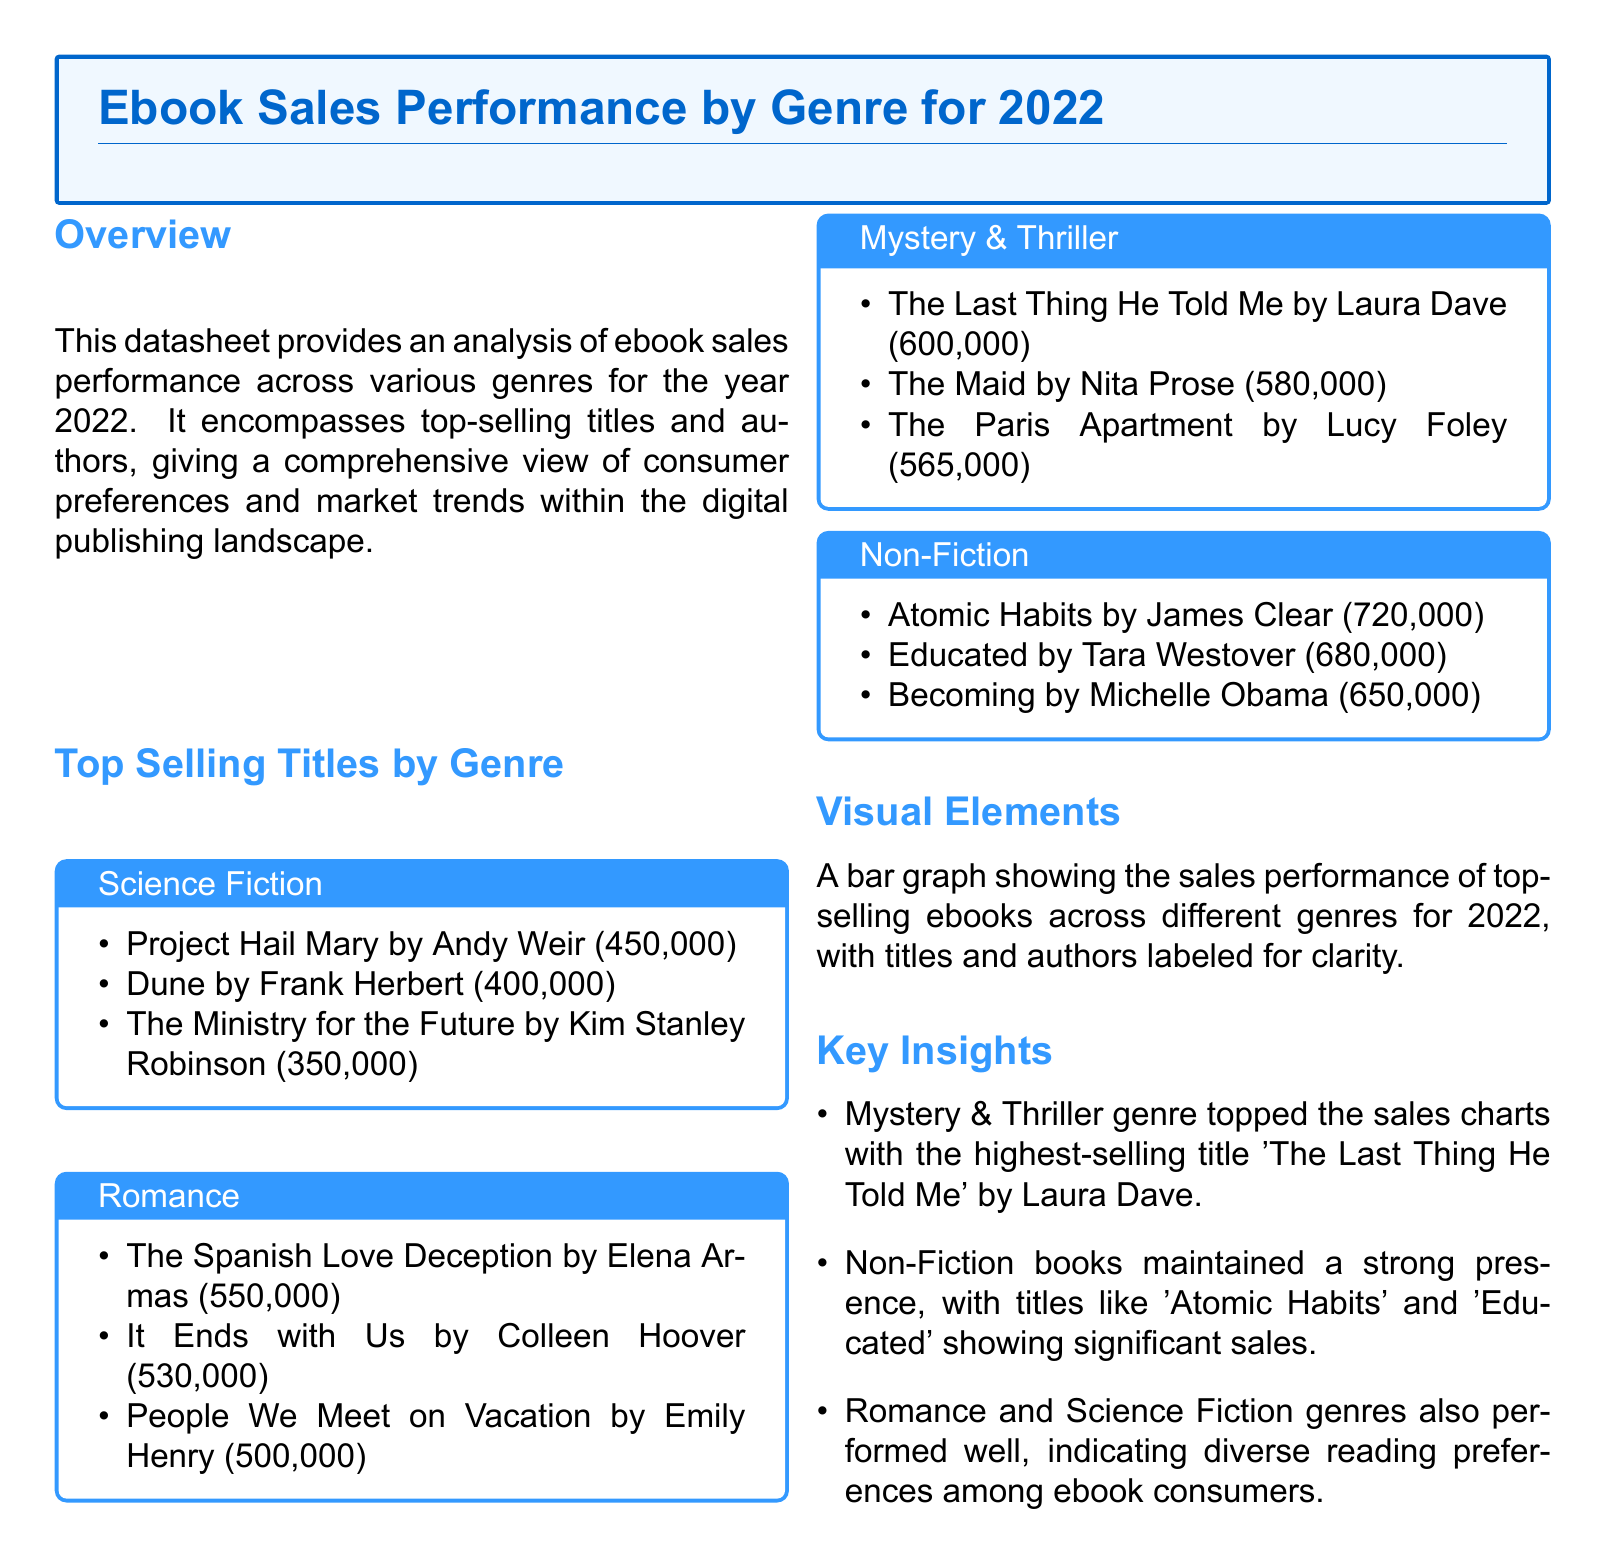what is the highest-selling title in the Mystery & Thriller genre? The highest-selling title is identified in the document under the Mystery & Thriller genre section.
Answer: The Last Thing He Told Me how many copies did Atomic Habits sell? The number of copies sold is specified in the Non-Fiction section of the document.
Answer: 720,000 which author wrote The Spanish Love Deception? The author of The Spanish Love Deception is listed in the Romance section.
Answer: Elena Armas what genre had the top-selling title in 2022? The genre corresponding to the highest-selling title is indicated under the Key Insights section.
Answer: Mystery & Thriller how many copies did The Ministry for the Future sell? The sales figures for The Ministry for the Future are provided in the Science Fiction section.
Answer: 350,000 which title sold 680,000 copies? The sales figure for this title is found in the Non-Fiction section.
Answer: Educated who is the author of the best-selling Romance title? The best-selling title in Romance is detailed, along with its author in the document.
Answer: Colleen Hoover what were the total sales of the top three Science Fiction titles? The total sales can be calculated from the sales figures listed in the Science Fiction section.
Answer: 1,200,000 what was the sales figure for People We Meet on Vacation? This title's sales figure is specified in the Romance section.
Answer: 500,000 